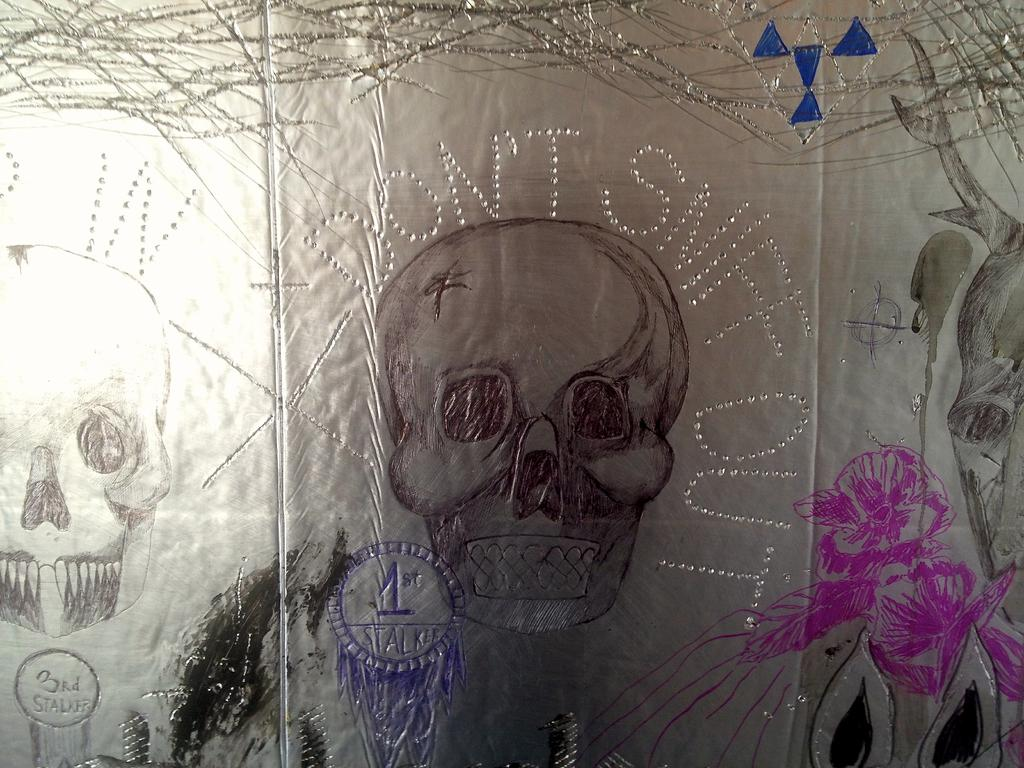What type of drawings can be seen in the image? There are skull drawings in the image. What is the medium of the drawings? The skull drawings are on a paper. Where can we find your uncle at the market in the image? There is no reference to an uncle, market, or loaf in the image; it only features skull drawings on a paper. 